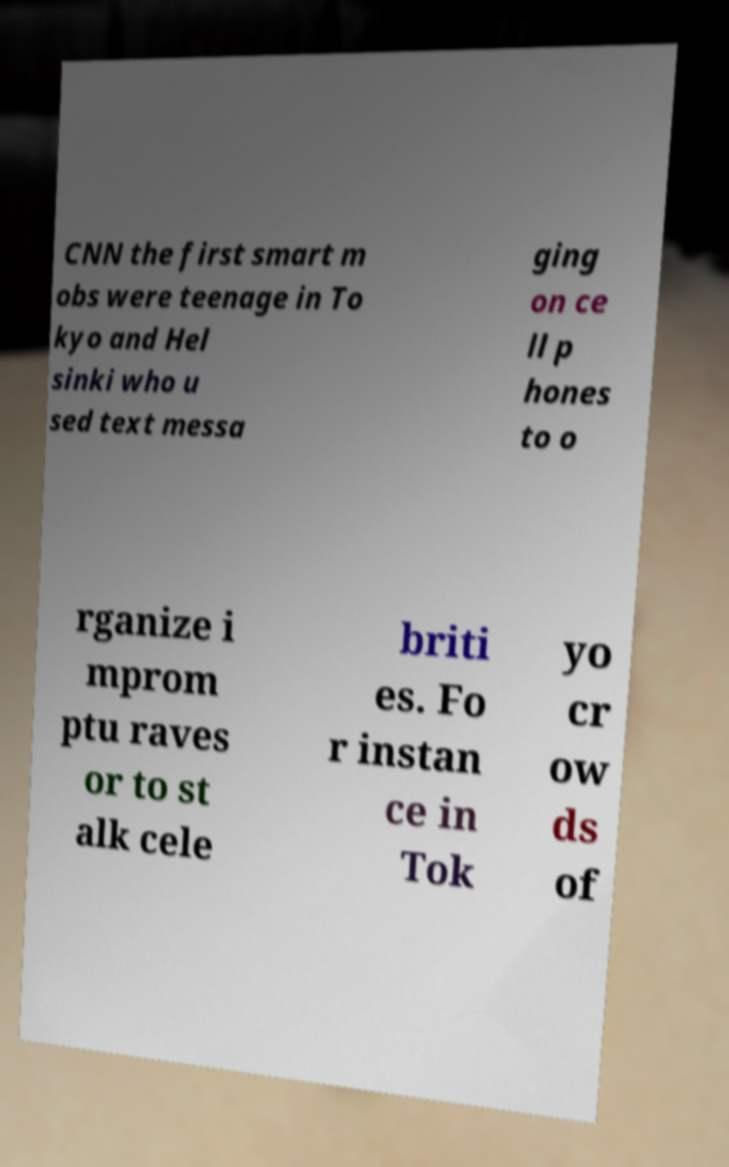Please read and relay the text visible in this image. What does it say? CNN the first smart m obs were teenage in To kyo and Hel sinki who u sed text messa ging on ce ll p hones to o rganize i mprom ptu raves or to st alk cele briti es. Fo r instan ce in Tok yo cr ow ds of 